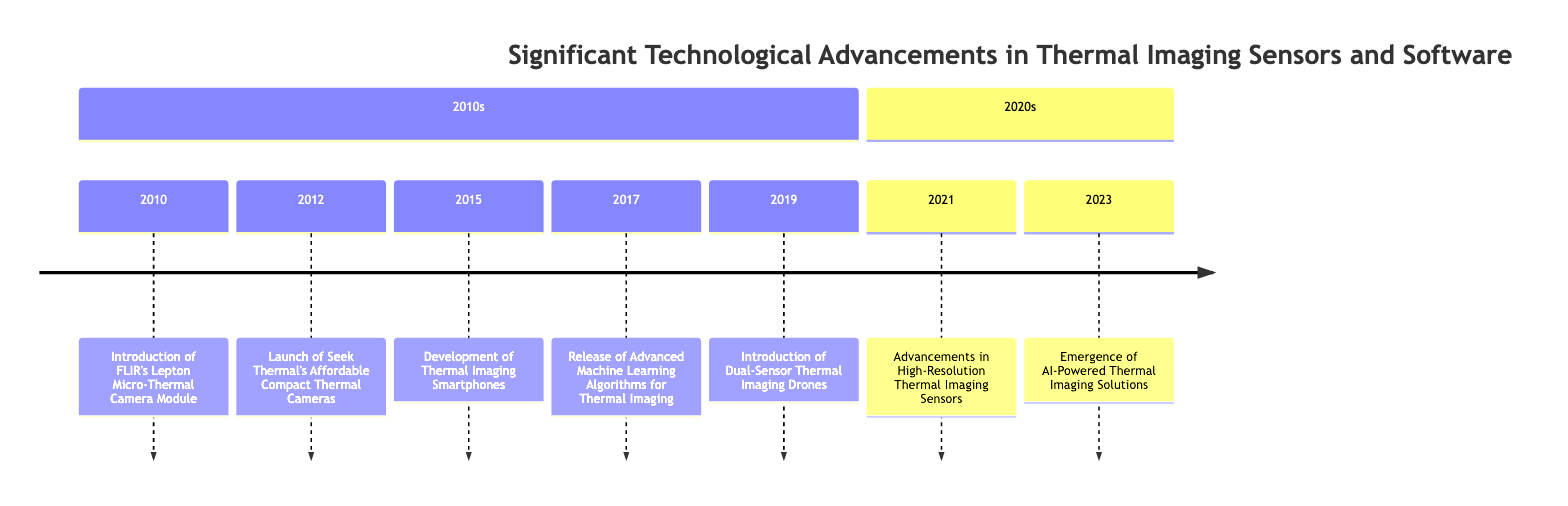What was introduced in 2010? The diagram indicates that in 2010, FLIR's Lepton Micro-Thermal Camera Module was introduced. This can be found directly connected to the year 2010 in the timeline.
Answer: FLIR's Lepton Micro-Thermal Camera Module How many significant advancements occurred in the 2010s? By counting the events listed in the 2010s section of the timeline, there are five significant advancements: one each in 2010, 2012, 2015, 2017, and 2019.
Answer: 5 What are the two events that occurred in 2021? Looking at the 2021 entry in the timeline, it mentions "Advancements in High-Resolution Thermal Imaging Sensors," which is the only event listed under that year. There are no two events; hence the answer is the only one found.
Answer: Advancements in High-Resolution Thermal Imaging Sensors Which advancement improved thermal image processing accuracy? Referring to the timeline, the release of advanced machine learning algorithms for thermal imaging in 2017 is specifically mentioned as improving accuracy and speed in image processing.
Answer: Advanced Machine Learning Algorithms for Thermal Imaging In what year did the introduction of dual-sensor thermal imaging drones occur? The timeline shows that the introduction of dual-sensor thermal imaging drones took place in 2019. This is noted under the year 2019 in the timeline.
Answer: 2019 What company launched affordable compact thermal cameras in 2012? The timeline indicates that Seek Thermal is the company that launched affordable compact thermal cameras in 2012. This information is directly stated alongside the event for that year.
Answer: Seek Thermal Which advancements occurred most recently according to the timeline? The most recent events according to the timeline are the "Emergence of AI-Powered Thermal Imaging Solutions" in 2023. This indicates that AI solutions have been incorporated into thermal imaging technology recently.
Answer: Emergence of AI-Powered Thermal Imaging Solutions What marked a notable trend for thermal imaging in the 2010s? The timeline provides several entries, but a notable trend is the development of portable solutions such as smartphones with thermal imaging capabilities in 2015. This reflects a shift towards accessibility in thermal imaging technology.
Answer: Development of Thermal Imaging Smartphones Which two advancements targeted the accessible use of thermal imaging? The timeline lists two events that emphasize accessibility: the introduction of FLIR's Lepton Micro-Thermal Camera Module in 2010 and the launch of Seek Thermal's affordable compact thermal cameras in 2012. These advancements made thermal imaging technology more widely available.
Answer: FLIR's Lepton Micro-Thermal Camera Module and Seek Thermal's Affordable Compact Thermal Cameras 